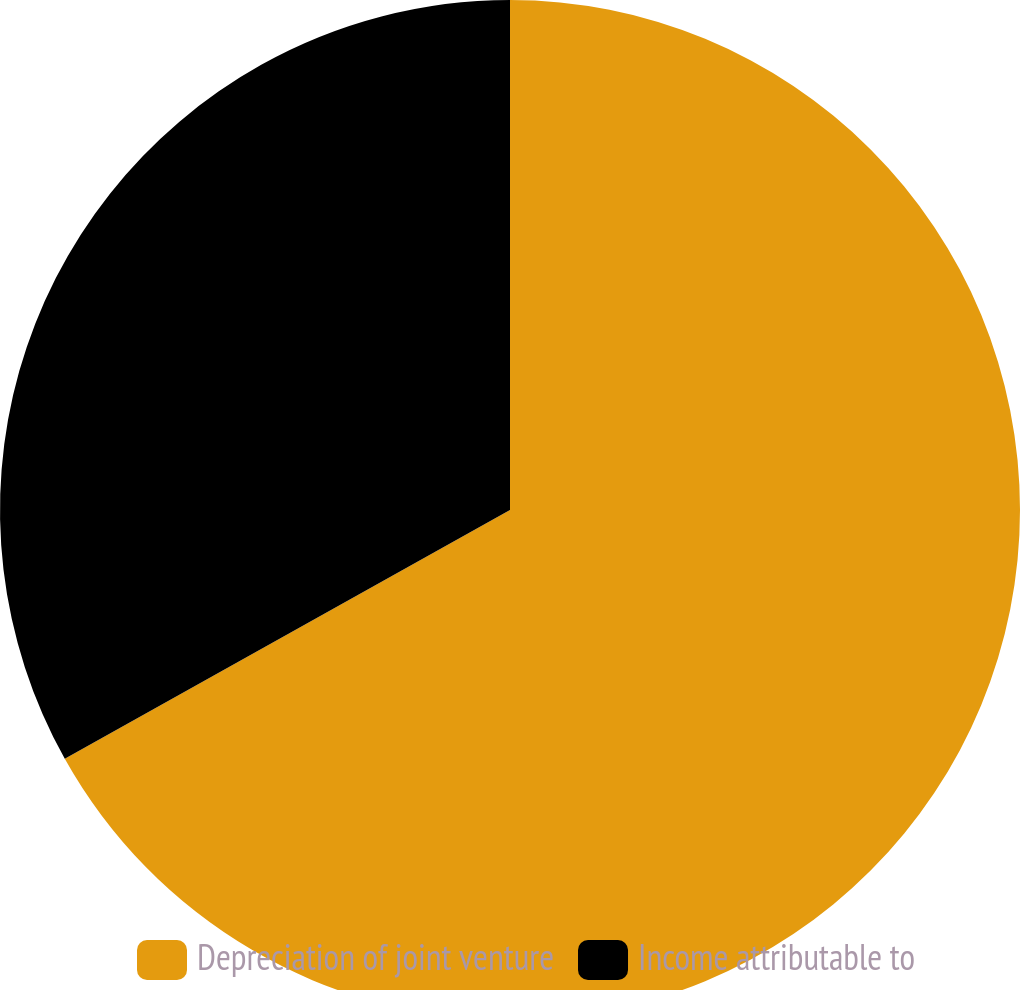Convert chart to OTSL. <chart><loc_0><loc_0><loc_500><loc_500><pie_chart><fcel>Depreciation of joint venture<fcel>Income attributable to<nl><fcel>66.89%<fcel>33.11%<nl></chart> 